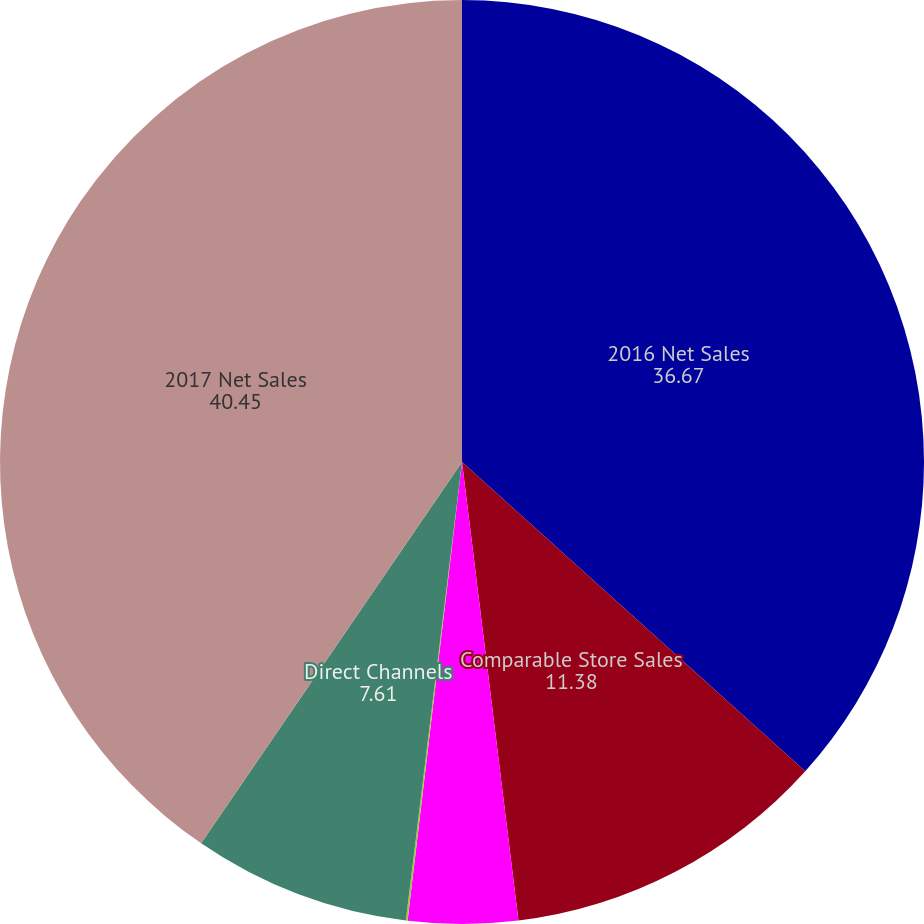Convert chart. <chart><loc_0><loc_0><loc_500><loc_500><pie_chart><fcel>2016 Net Sales<fcel>Comparable Store Sales<fcel>Sales Associated with New<fcel>Foreign Currency Translation<fcel>Direct Channels<fcel>2017 Net Sales<nl><fcel>36.67%<fcel>11.38%<fcel>3.83%<fcel>0.06%<fcel>7.61%<fcel>40.45%<nl></chart> 